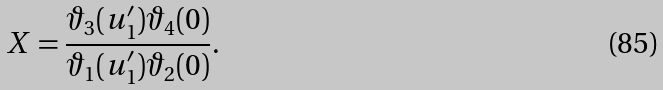Convert formula to latex. <formula><loc_0><loc_0><loc_500><loc_500>X = \frac { \vartheta _ { 3 } ( u _ { 1 } ^ { \prime } ) \vartheta _ { 4 } ( 0 ) } { \vartheta _ { 1 } ( u _ { 1 } ^ { \prime } ) \vartheta _ { 2 } ( 0 ) } .</formula> 